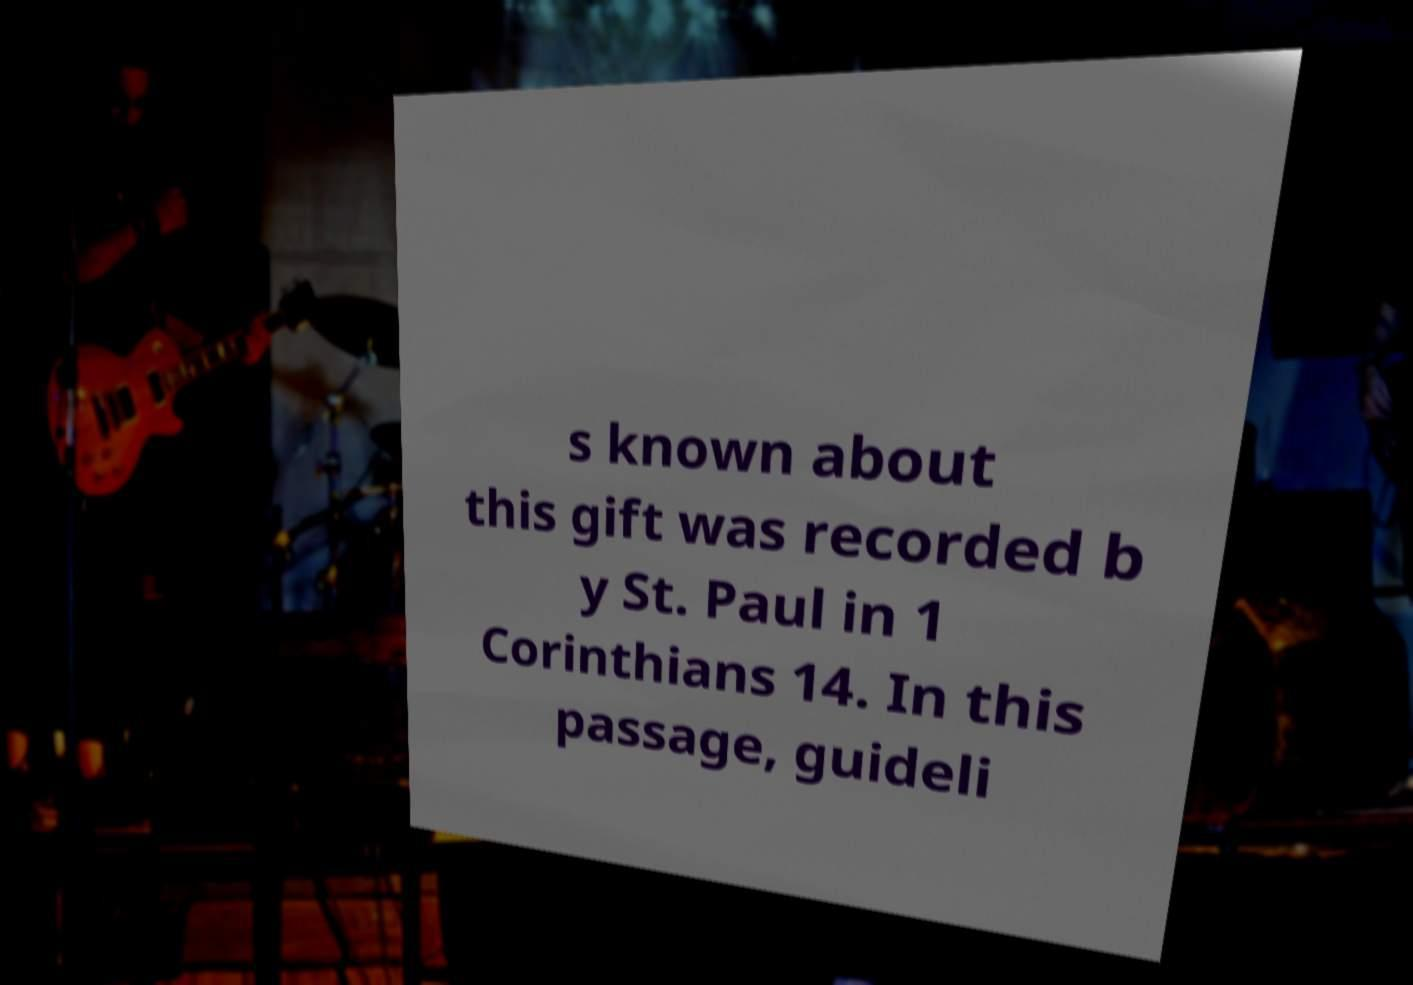Please read and relay the text visible in this image. What does it say? s known about this gift was recorded b y St. Paul in 1 Corinthians 14. In this passage, guideli 